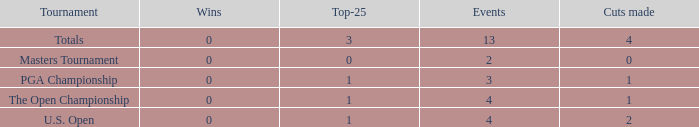How many cuts made in the tournament he played 13 times? None. 